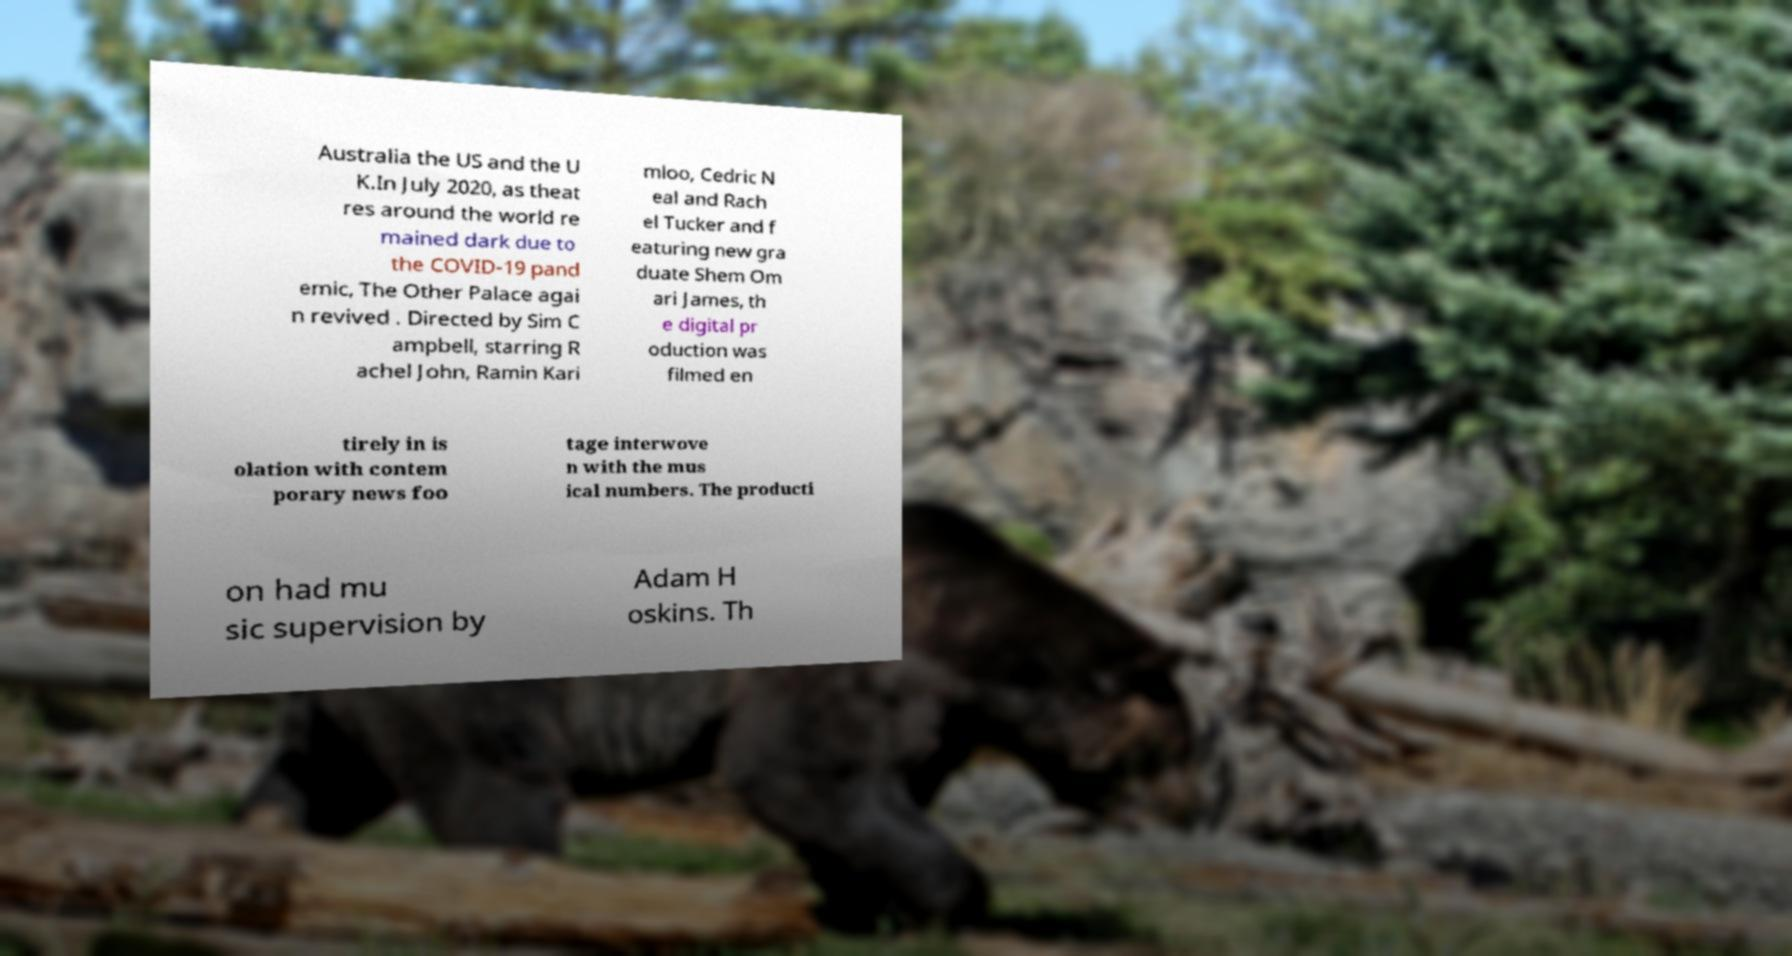For documentation purposes, I need the text within this image transcribed. Could you provide that? Australia the US and the U K.In July 2020, as theat res around the world re mained dark due to the COVID-19 pand emic, The Other Palace agai n revived . Directed by Sim C ampbell, starring R achel John, Ramin Kari mloo, Cedric N eal and Rach el Tucker and f eaturing new gra duate Shem Om ari James, th e digital pr oduction was filmed en tirely in is olation with contem porary news foo tage interwove n with the mus ical numbers. The producti on had mu sic supervision by Adam H oskins. Th 